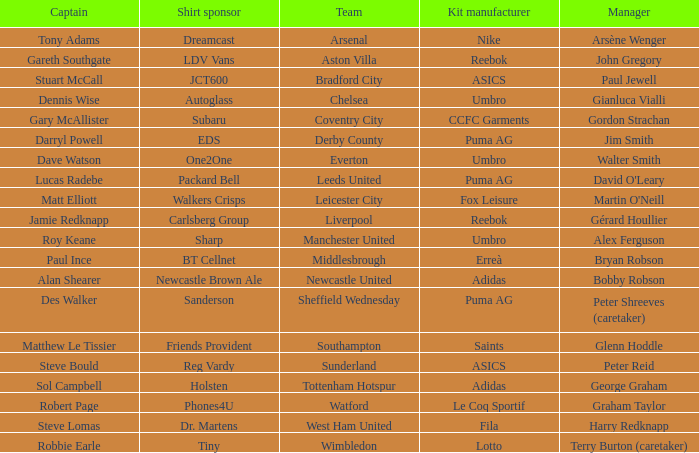Which captain is managed by gianluca vialli? Dennis Wise. 